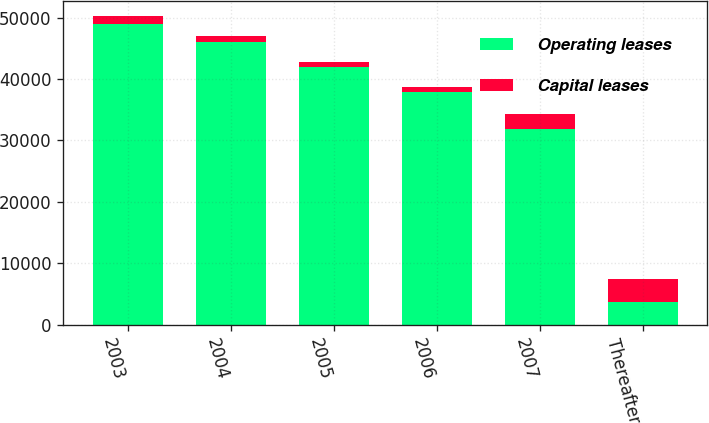<chart> <loc_0><loc_0><loc_500><loc_500><stacked_bar_chart><ecel><fcel>2003<fcel>2004<fcel>2005<fcel>2006<fcel>2007<fcel>Thereafter<nl><fcel>Operating leases<fcel>48916<fcel>46067<fcel>41959<fcel>37930<fcel>31902<fcel>3738<nl><fcel>Capital leases<fcel>1289<fcel>924<fcel>811<fcel>810<fcel>2389<fcel>3738<nl></chart> 